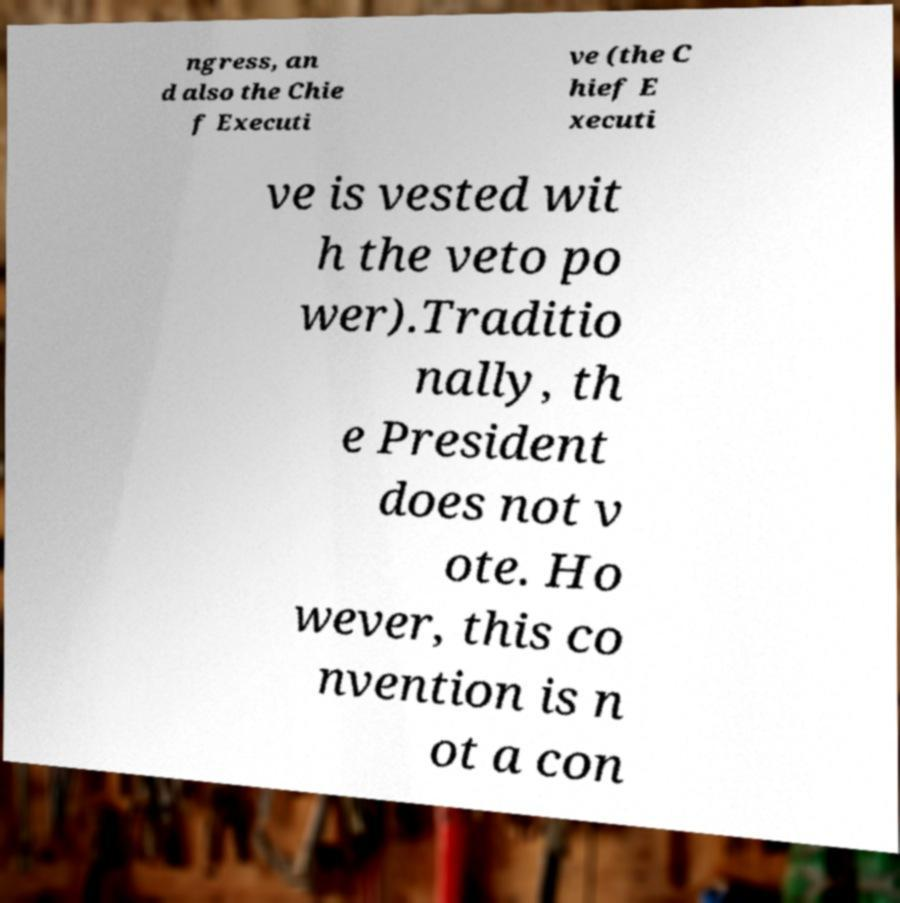Could you assist in decoding the text presented in this image and type it out clearly? ngress, an d also the Chie f Executi ve (the C hief E xecuti ve is vested wit h the veto po wer).Traditio nally, th e President does not v ote. Ho wever, this co nvention is n ot a con 